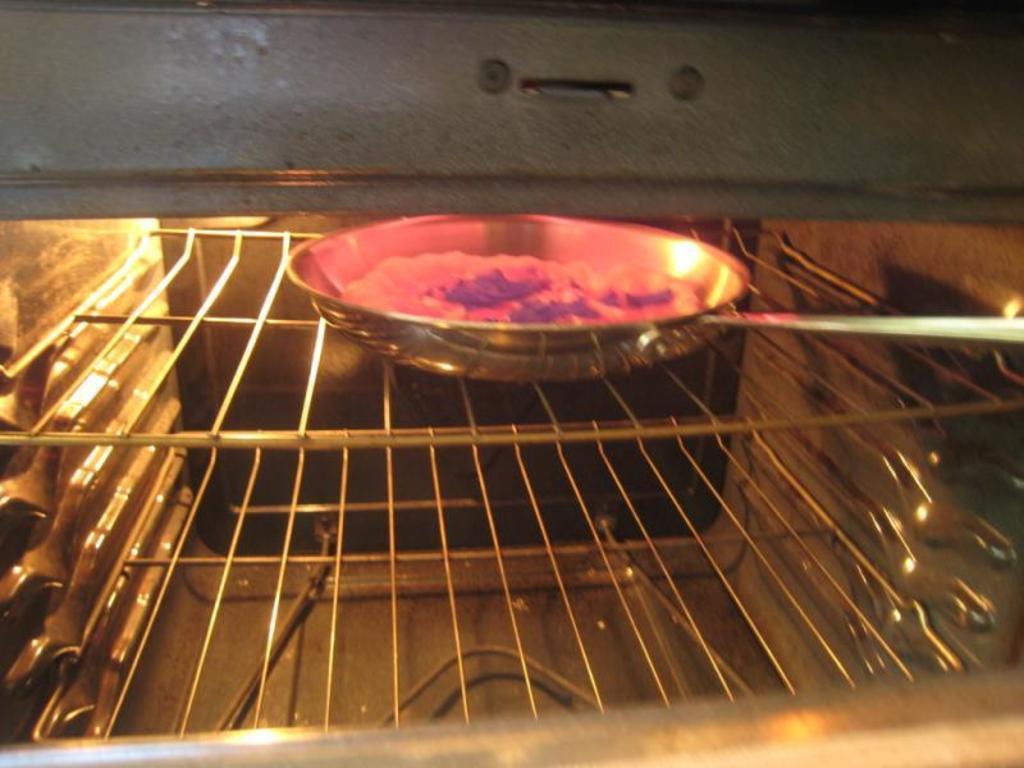In one or two sentences, can you explain what this image depicts? In the picture I can see a steel pan on a grill. I can also see something in the pan. 